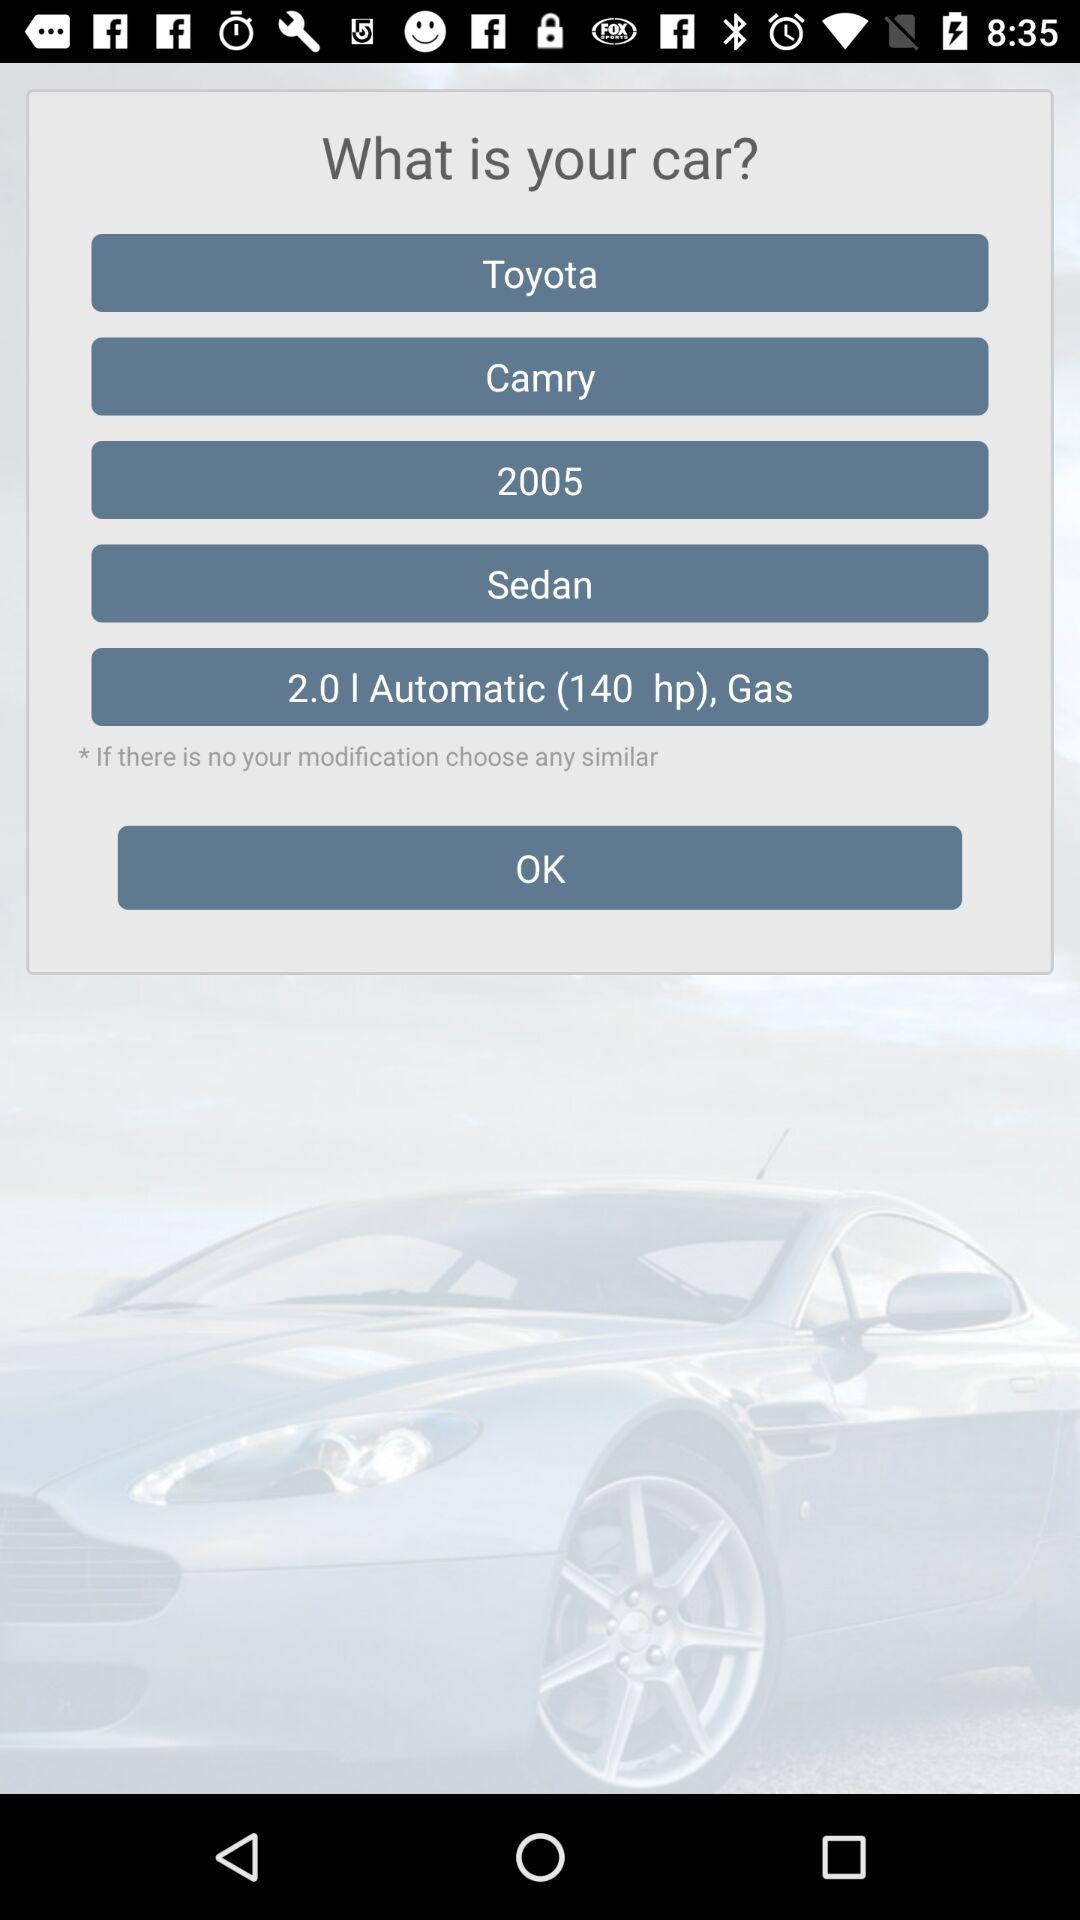What is the car model? The car model is "Camry". 